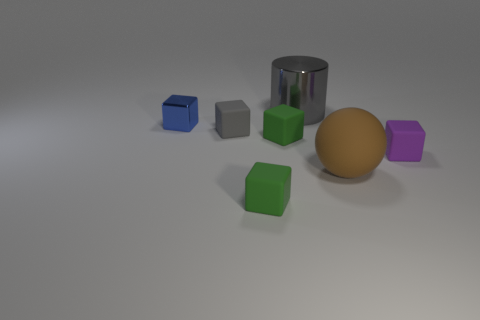Subtract all gray cubes. How many cubes are left? 4 Subtract 2 blocks. How many blocks are left? 3 Subtract all purple matte cubes. How many cubes are left? 4 Subtract all yellow blocks. Subtract all gray spheres. How many blocks are left? 5 Add 2 green rubber blocks. How many objects exist? 9 Subtract all cylinders. How many objects are left? 6 Add 1 large brown matte spheres. How many large brown matte spheres are left? 2 Add 2 tiny green matte objects. How many tiny green matte objects exist? 4 Subtract 1 gray cubes. How many objects are left? 6 Subtract all big gray objects. Subtract all big things. How many objects are left? 4 